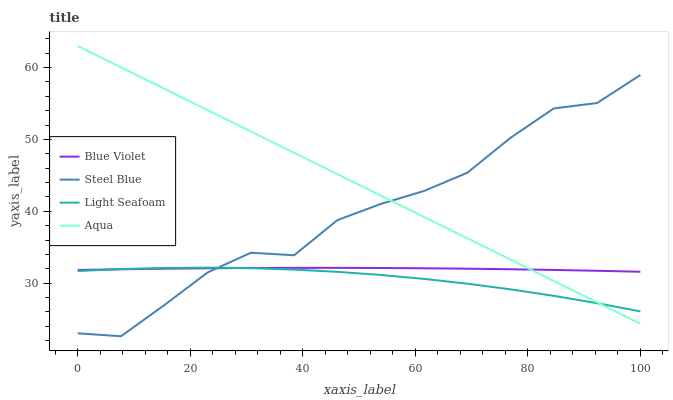Does Light Seafoam have the minimum area under the curve?
Answer yes or no. Yes. Does Aqua have the maximum area under the curve?
Answer yes or no. Yes. Does Steel Blue have the minimum area under the curve?
Answer yes or no. No. Does Steel Blue have the maximum area under the curve?
Answer yes or no. No. Is Aqua the smoothest?
Answer yes or no. Yes. Is Steel Blue the roughest?
Answer yes or no. Yes. Is Steel Blue the smoothest?
Answer yes or no. No. Is Aqua the roughest?
Answer yes or no. No. Does Aqua have the lowest value?
Answer yes or no. No. Does Aqua have the highest value?
Answer yes or no. Yes. Does Steel Blue have the highest value?
Answer yes or no. No. Does Steel Blue intersect Blue Violet?
Answer yes or no. Yes. Is Steel Blue less than Blue Violet?
Answer yes or no. No. Is Steel Blue greater than Blue Violet?
Answer yes or no. No. 